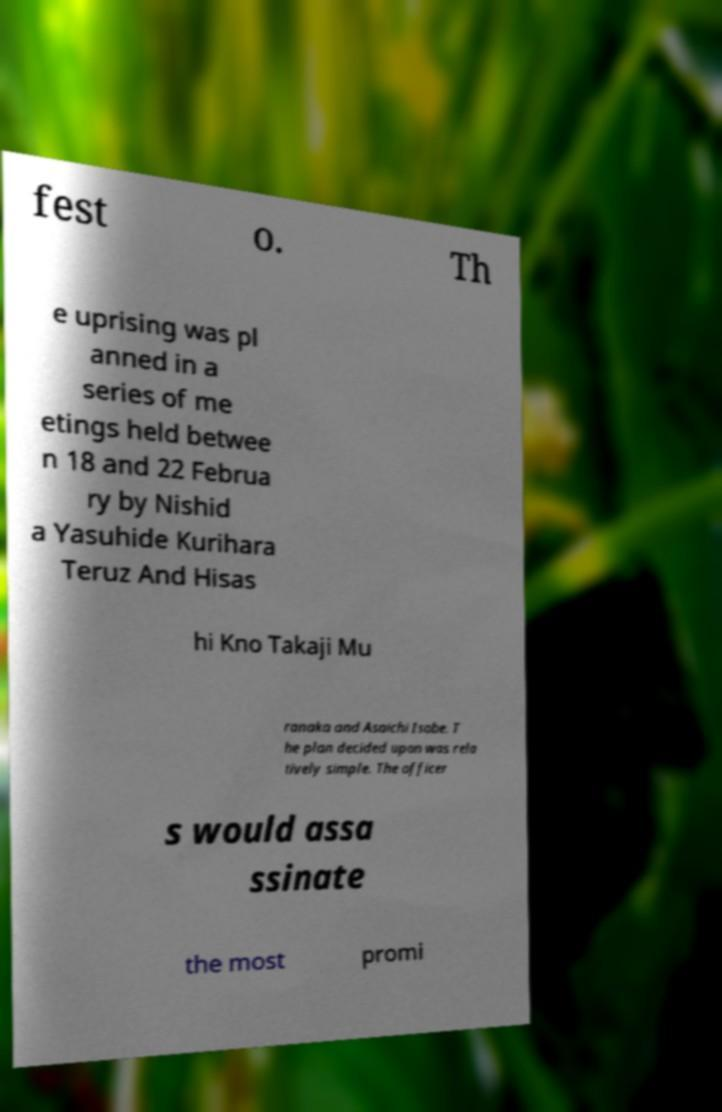Can you read and provide the text displayed in the image?This photo seems to have some interesting text. Can you extract and type it out for me? fest o. Th e uprising was pl anned in a series of me etings held betwee n 18 and 22 Februa ry by Nishid a Yasuhide Kurihara Teruz And Hisas hi Kno Takaji Mu ranaka and Asaichi Isobe. T he plan decided upon was rela tively simple. The officer s would assa ssinate the most promi 